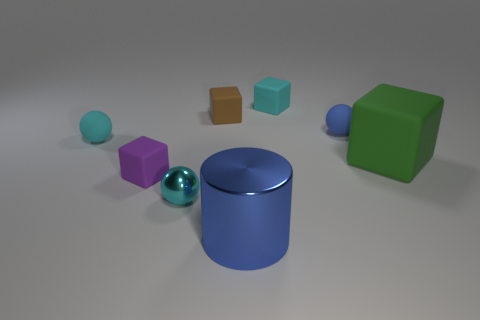There is a cyan thing in front of the tiny rubber ball that is to the left of the blue shiny cylinder; how many tiny cyan matte objects are right of it? In the depicted scene, we can observe a single cyan cube positioned to the right of the tiny rubber ball. This object exhibits a matte finish, distinguishing it from the shinier surfaces of other items in the vicinity. Consequently, there is one tiny cyan matte object located to the right of the rubber ball. 